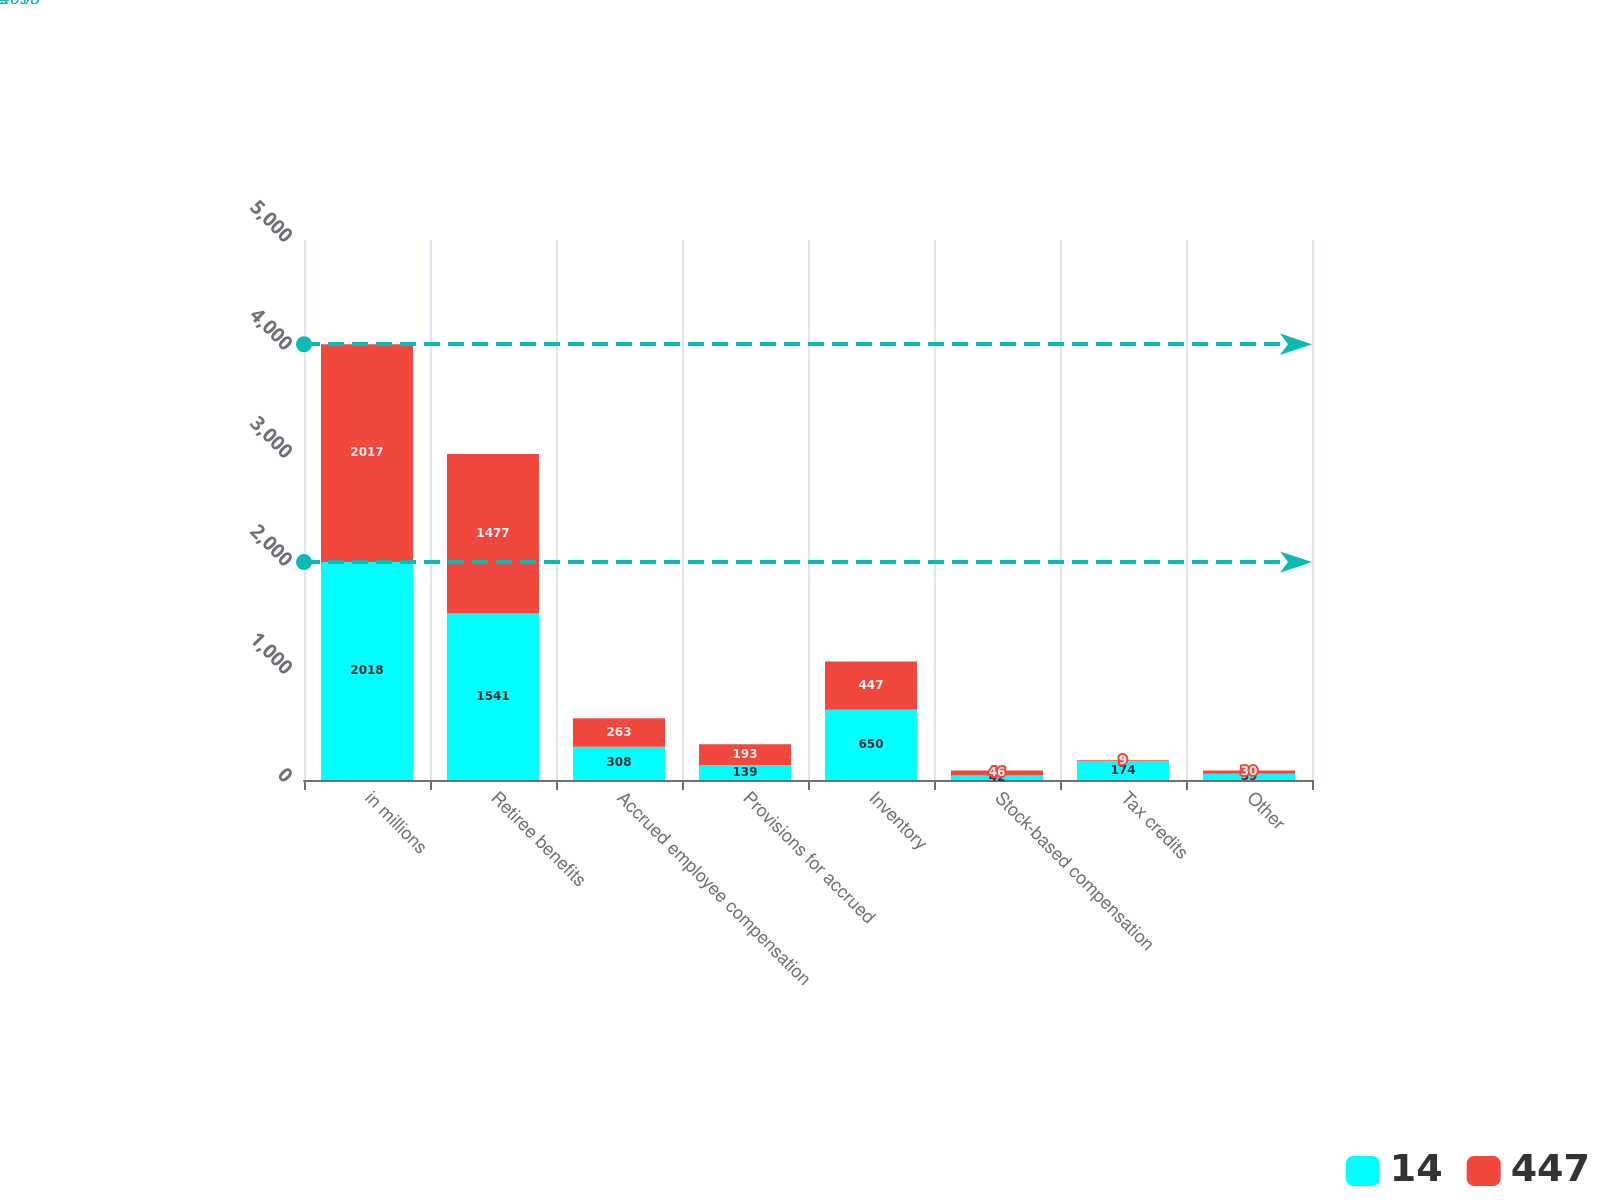Convert chart. <chart><loc_0><loc_0><loc_500><loc_500><stacked_bar_chart><ecel><fcel>in millions<fcel>Retiree benefits<fcel>Accrued employee compensation<fcel>Provisions for accrued<fcel>Inventory<fcel>Stock-based compensation<fcel>Tax credits<fcel>Other<nl><fcel>14<fcel>2018<fcel>1541<fcel>308<fcel>139<fcel>650<fcel>42<fcel>174<fcel>59<nl><fcel>447<fcel>2017<fcel>1477<fcel>263<fcel>193<fcel>447<fcel>46<fcel>9<fcel>30<nl></chart> 